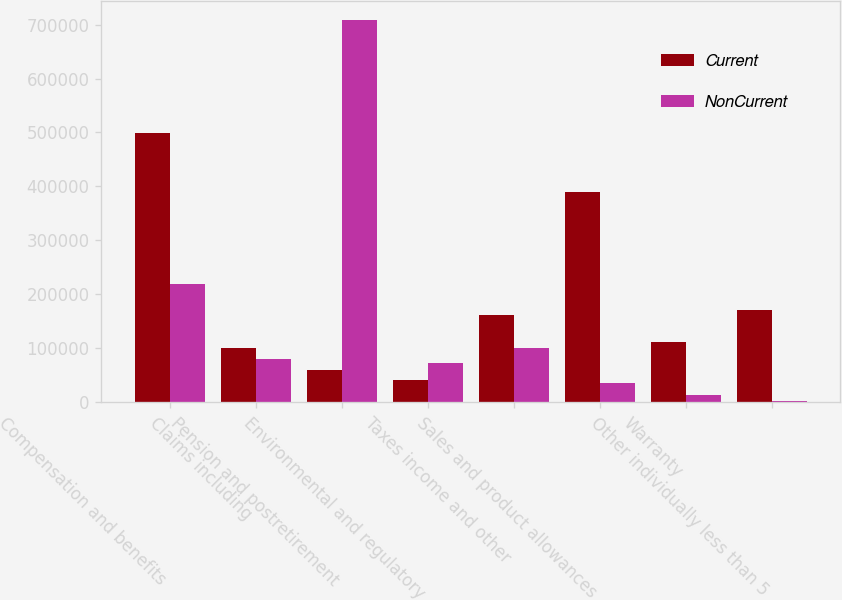Convert chart to OTSL. <chart><loc_0><loc_0><loc_500><loc_500><stacked_bar_chart><ecel><fcel>Compensation and benefits<fcel>Claims including<fcel>Pension and postretirement<fcel>Environmental and regulatory<fcel>Taxes income and other<fcel>Sales and product allowances<fcel>Warranty<fcel>Other individually less than 5<nl><fcel>Current<fcel>499130<fcel>100643<fcel>60100<fcel>41638<fcel>161937<fcel>389533<fcel>111910<fcel>170539<nl><fcel>NonCurrent<fcel>219797<fcel>80334<fcel>709000<fcel>72164<fcel>100643<fcel>36190<fcel>13000<fcel>3004<nl></chart> 